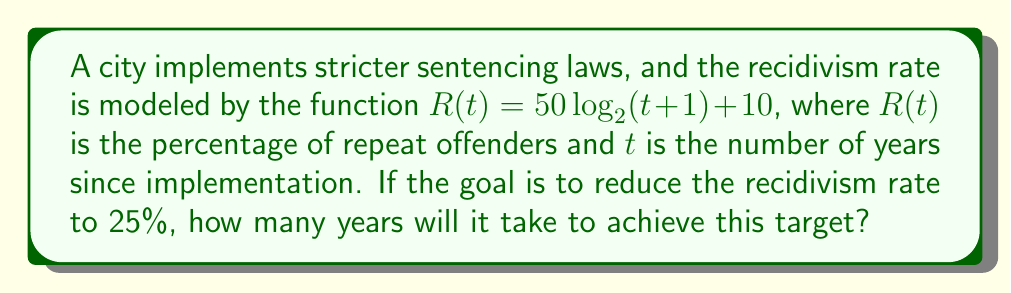Solve this math problem. To solve this problem, we need to follow these steps:

1) We want to find $t$ when $R(t) = 25$. So, we set up the equation:
   
   $25 = 50 \log_2(t+1) + 10$

2) Subtract 10 from both sides:
   
   $15 = 50 \log_2(t+1)$

3) Divide both sides by 50:
   
   $0.3 = \log_2(t+1)$

4) To solve for $t$, we need to apply the inverse function (exponential) to both sides:
   
   $2^{0.3} = t+1$

5) Calculate $2^{0.3}$:
   
   $2^{0.3} \approx 1.2311$

6) Subtract 1 from both sides to isolate $t$:
   
   $t \approx 0.2311$

7) Since $t$ represents years, we need to round up to the nearest whole year:
   
   $t = 1$

Therefore, it will take 1 year for the recidivism rate to drop to 25% under this model.
Answer: 1 year 